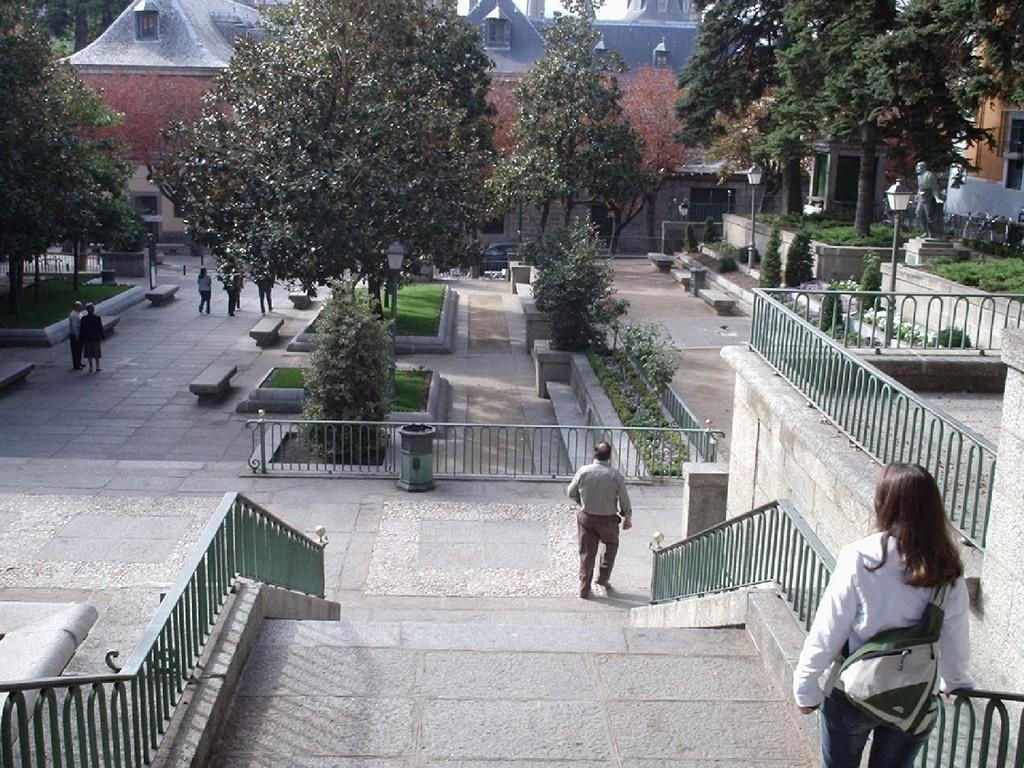How many people are in the image? There are persons in the image, but the exact number is not specified. What architectural feature can be seen in the image? There are stairs in the image. What type of barrier is present in the image? There is fencing in the image. What type of vegetation is visible in the image? There are trees, grass, and plants in the image. What type of lighting is present in the image? There are streetlights in the image. What type of artwork is present in the image? There is a statue in the image. What type of seating is present in the image? There are benches in the image. What type of story is the maid telling at breakfast in the image? There is no mention of a story, maid, or breakfast in the image. 